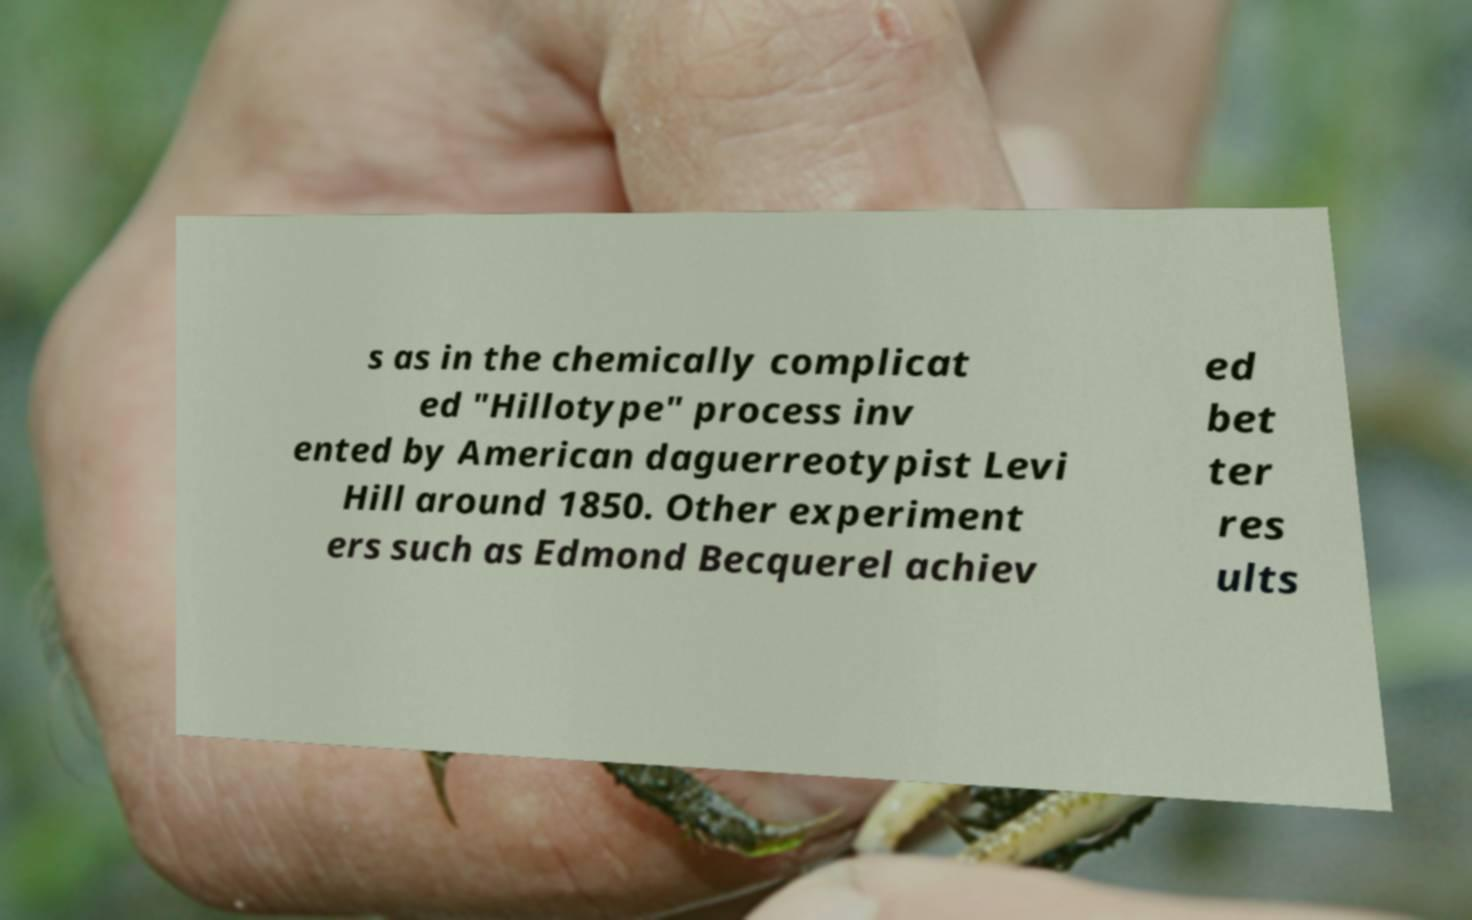For documentation purposes, I need the text within this image transcribed. Could you provide that? s as in the chemically complicat ed "Hillotype" process inv ented by American daguerreotypist Levi Hill around 1850. Other experiment ers such as Edmond Becquerel achiev ed bet ter res ults 